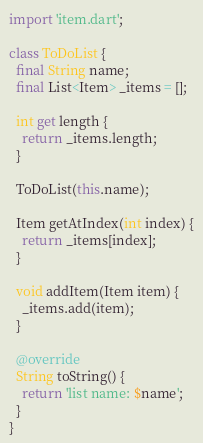<code> <loc_0><loc_0><loc_500><loc_500><_Dart_>import 'item.dart';

class ToDoList {
  final String name;
  final List<Item> _items = [];

  int get length {
    return _items.length;
  }

  ToDoList(this.name);

  Item getAtIndex(int index) {
    return _items[index];
  }

  void addItem(Item item) {
    _items.add(item);
  }

  @override
  String toString() {
    return 'list name: $name';
  }
}
</code> 